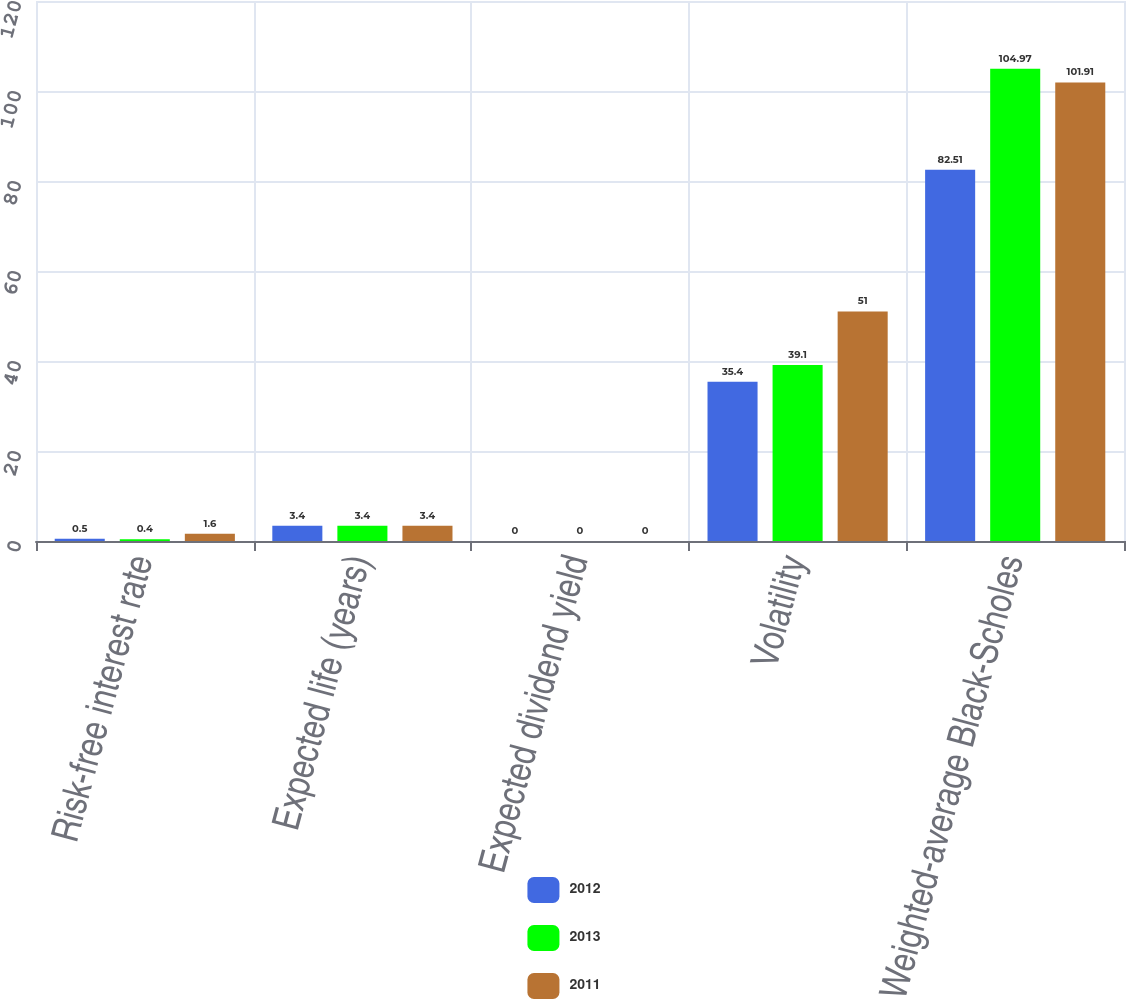Convert chart. <chart><loc_0><loc_0><loc_500><loc_500><stacked_bar_chart><ecel><fcel>Risk-free interest rate<fcel>Expected life (years)<fcel>Expected dividend yield<fcel>Volatility<fcel>Weighted-average Black-Scholes<nl><fcel>2012<fcel>0.5<fcel>3.4<fcel>0<fcel>35.4<fcel>82.51<nl><fcel>2013<fcel>0.4<fcel>3.4<fcel>0<fcel>39.1<fcel>104.97<nl><fcel>2011<fcel>1.6<fcel>3.4<fcel>0<fcel>51<fcel>101.91<nl></chart> 